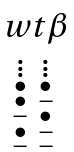Convert formula to latex. <formula><loc_0><loc_0><loc_500><loc_500>\begin{matrix} \ w t { \beta } \\ \begin{smallmatrix} \vdots & \vdots \\ \bullet & \bullet \\ \bullet & - \\ - & \bullet \\ \bullet & - \\ - & - \end{smallmatrix} \end{matrix}</formula> 